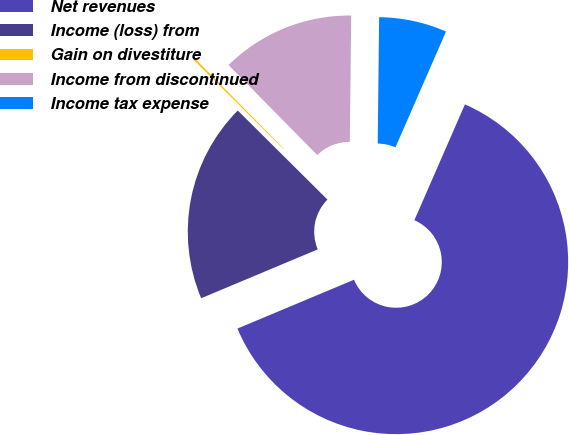<chart> <loc_0><loc_0><loc_500><loc_500><pie_chart><fcel>Net revenues<fcel>Income (loss) from<fcel>Gain on divestiture<fcel>Income from discontinued<fcel>Income tax expense<nl><fcel>62.13%<fcel>18.76%<fcel>0.17%<fcel>12.56%<fcel>6.37%<nl></chart> 